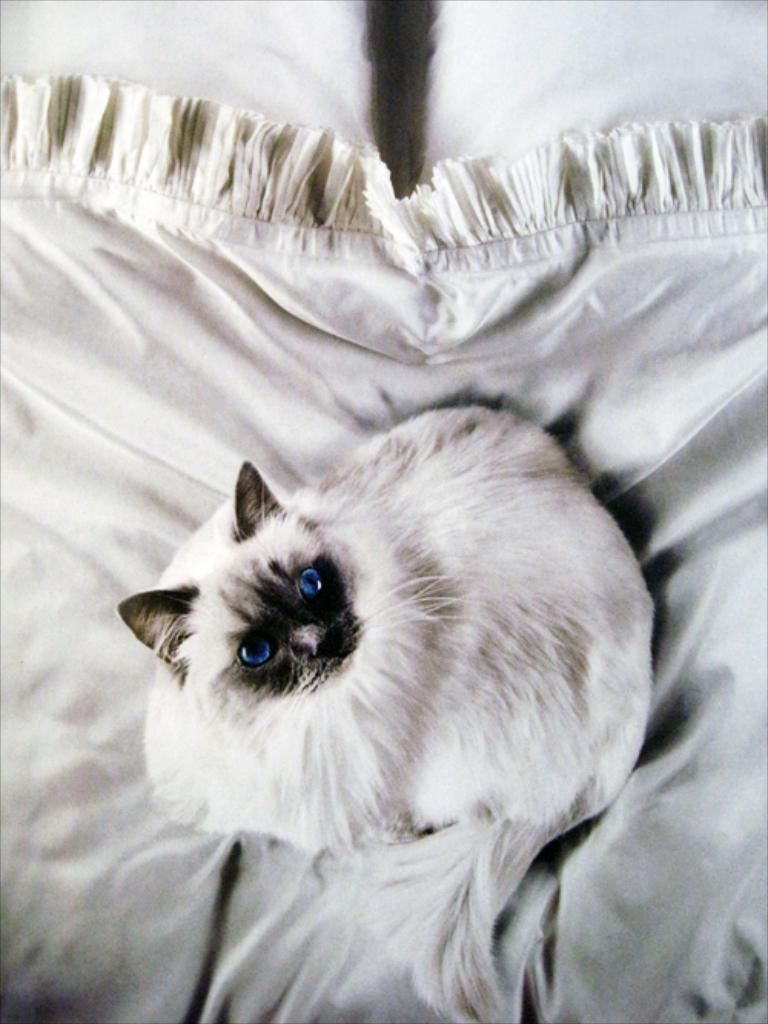What type of animal is in the image? There is a cat in the image. Can you describe the coloring of the cat? The cat has white and black coloring. What is the cat sitting on in the image? The cat is on a white color cloth. What type of skin condition does the woman in the image have? There is no woman present in the image, only a cat. Is there a bomb visible in the image? No, there is no bomb present in the image. 